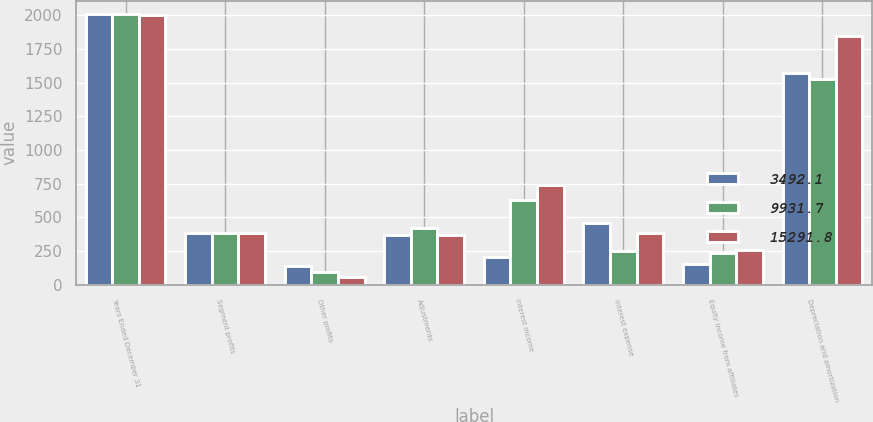<chart> <loc_0><loc_0><loc_500><loc_500><stacked_bar_chart><ecel><fcel>Years Ended December 31<fcel>Segment profits<fcel>Other profits<fcel>Adjustments<fcel>Interest income<fcel>Interest expense<fcel>Equity income from affiliates<fcel>Depreciation and amortization<nl><fcel>3492.1<fcel>2009<fcel>384.3<fcel>136.7<fcel>372<fcel>210.2<fcel>458<fcel>153.2<fcel>1569.6<nl><fcel>9931.7<fcel>2008<fcel>384.3<fcel>92.3<fcel>424.7<fcel>631.4<fcel>251.3<fcel>236.5<fcel>1529.8<nl><fcel>15291.8<fcel>2007<fcel>384.3<fcel>56.2<fcel>367.7<fcel>741.1<fcel>384.3<fcel>260.6<fcel>1851<nl></chart> 